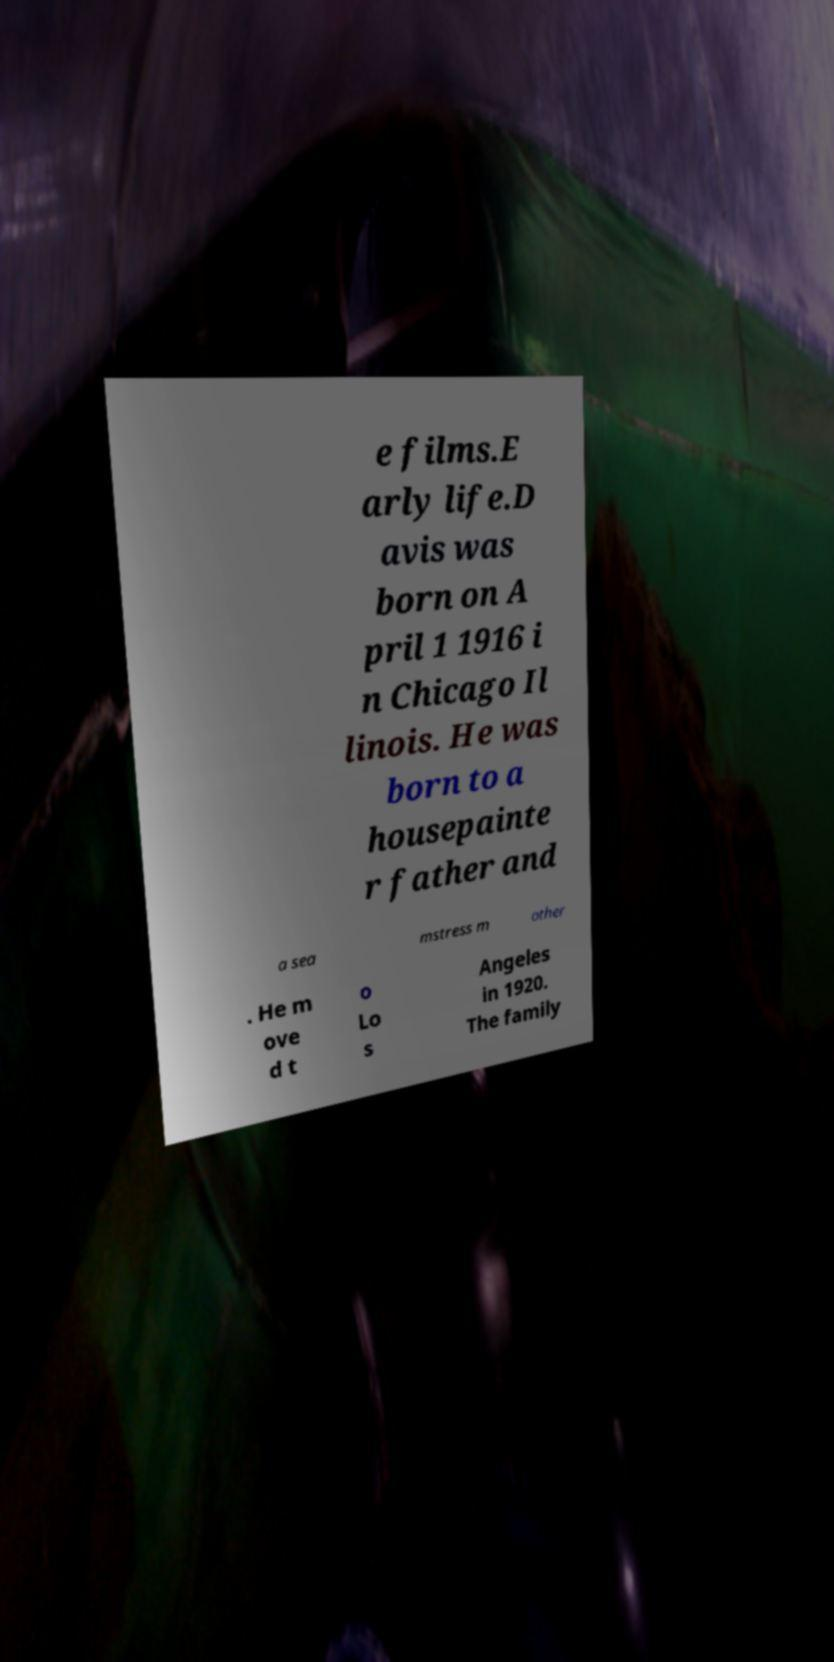Can you read and provide the text displayed in the image?This photo seems to have some interesting text. Can you extract and type it out for me? e films.E arly life.D avis was born on A pril 1 1916 i n Chicago Il linois. He was born to a housepainte r father and a sea mstress m other . He m ove d t o Lo s Angeles in 1920. The family 